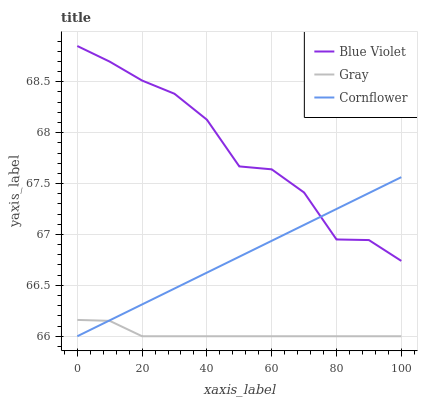Does Cornflower have the minimum area under the curve?
Answer yes or no. No. Does Cornflower have the maximum area under the curve?
Answer yes or no. No. Is Blue Violet the smoothest?
Answer yes or no. No. Is Cornflower the roughest?
Answer yes or no. No. Does Blue Violet have the lowest value?
Answer yes or no. No. Does Cornflower have the highest value?
Answer yes or no. No. Is Gray less than Blue Violet?
Answer yes or no. Yes. Is Blue Violet greater than Gray?
Answer yes or no. Yes. Does Gray intersect Blue Violet?
Answer yes or no. No. 